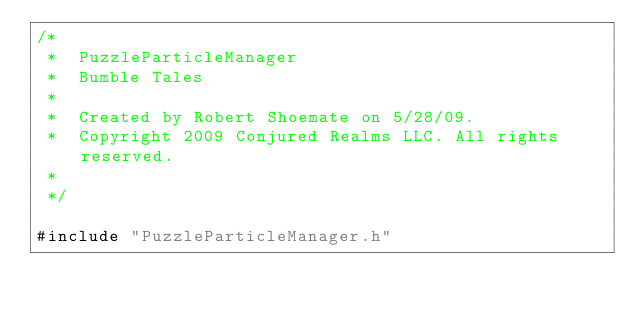Convert code to text. <code><loc_0><loc_0><loc_500><loc_500><_ObjectiveC_>/*
 *  PuzzleParticleManager
 *  Bumble Tales
 *
 *  Created by Robert Shoemate on 5/28/09.
 *  Copyright 2009 Conjured Realms LLC. All rights reserved.
 *
 */

#include "PuzzleParticleManager.h"

</code> 